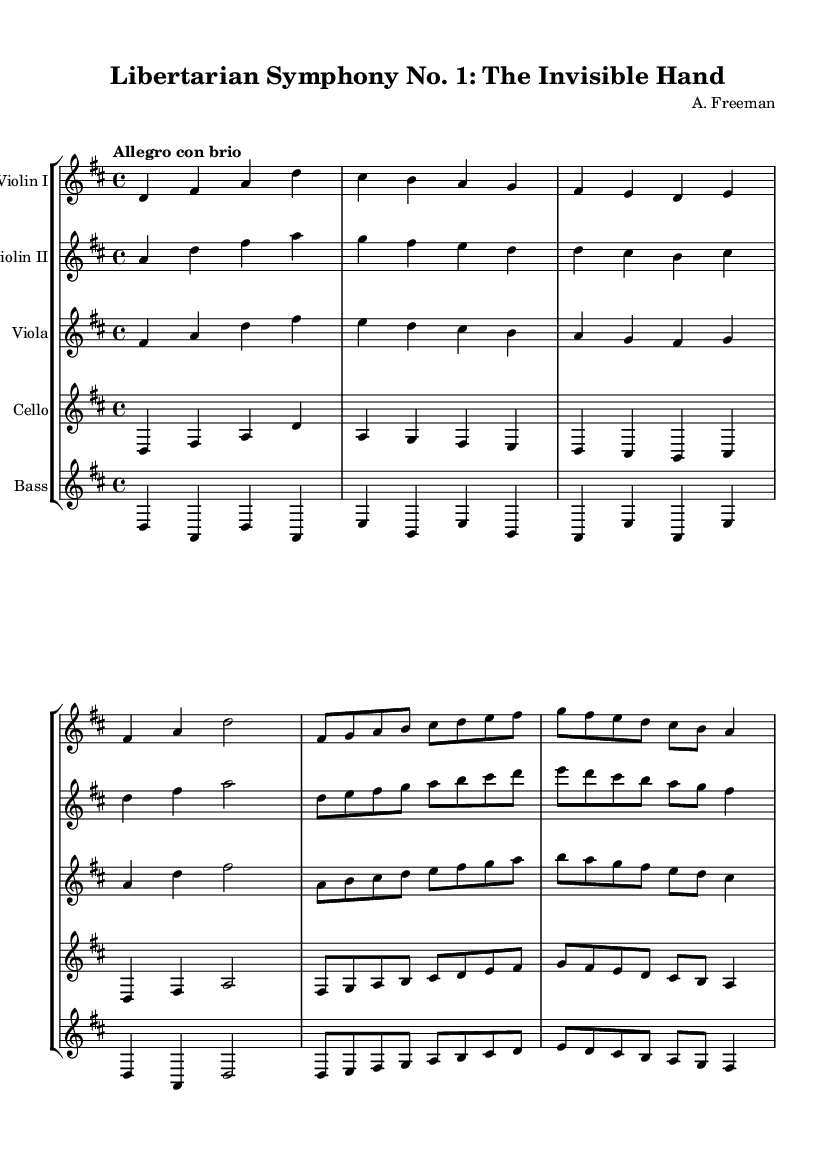What is the key signature of this music? The key signature is indicated with sharps or flats at the beginning of the staff; this piece shows two sharps, which correspond to D major.
Answer: D major What is the time signature of this music? The time signature is noted at the beginning of the staff and shows a "4/4" marking, indicating four beats per measure with a quarter note receiving one beat.
Answer: 4/4 What is the tempo marking for this piece? The tempo marking is typically indicated above the staff; in this score, it states "Allegro con brio," which suggests a fast tempo with vigor.
Answer: Allegro con brio How many measures are in the main theme? To find the number of measures, count the distinct groups of notes separated by vertical lines, called bar lines; the main theme contains four measures.
Answer: 4 What instruments are featured in this score? The instruments are listed at the beginning of each staff; the score features Violin I, Violin II, Viola, Cello, and Bass.
Answer: Violin I, Violin II, Viola, Cello, Bass Which theme appears first in this piece? By examining the order of the sections, the main theme is presented before the secondary theme, as indicated by their placement in the score.
Answer: Main theme What is the overall mood conveyed by the tempo and dynamic markings? The mood is typically interpreted based on the tempo and dynamics; "Allegro con brio" suggests a lively and spirited character, often associated with themes of individual freedom or triumph.
Answer: Lively and spirited 